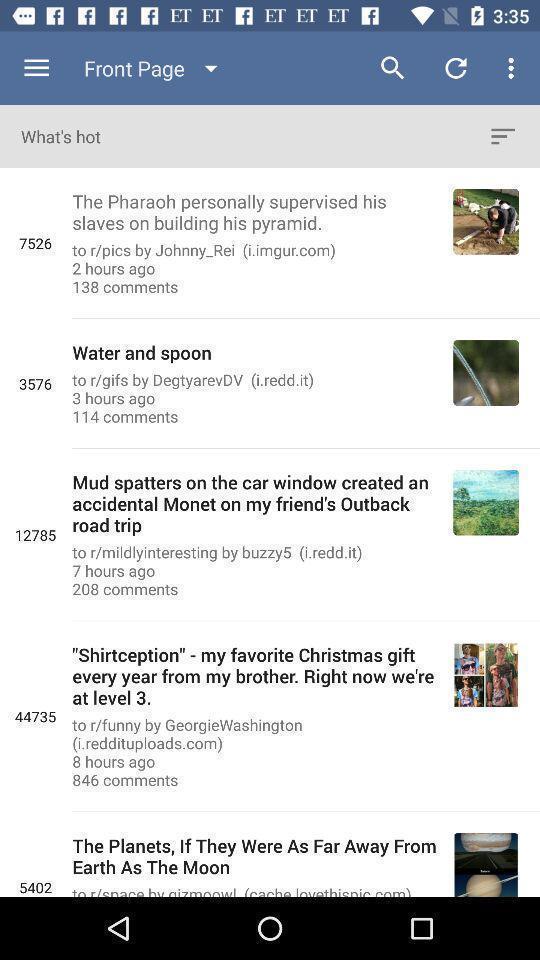Summarize the main components in this picture. Screen showing front page of a news app. 